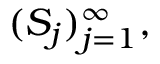<formula> <loc_0><loc_0><loc_500><loc_500>( S _ { j } ) _ { j = 1 } ^ { \infty } ,</formula> 